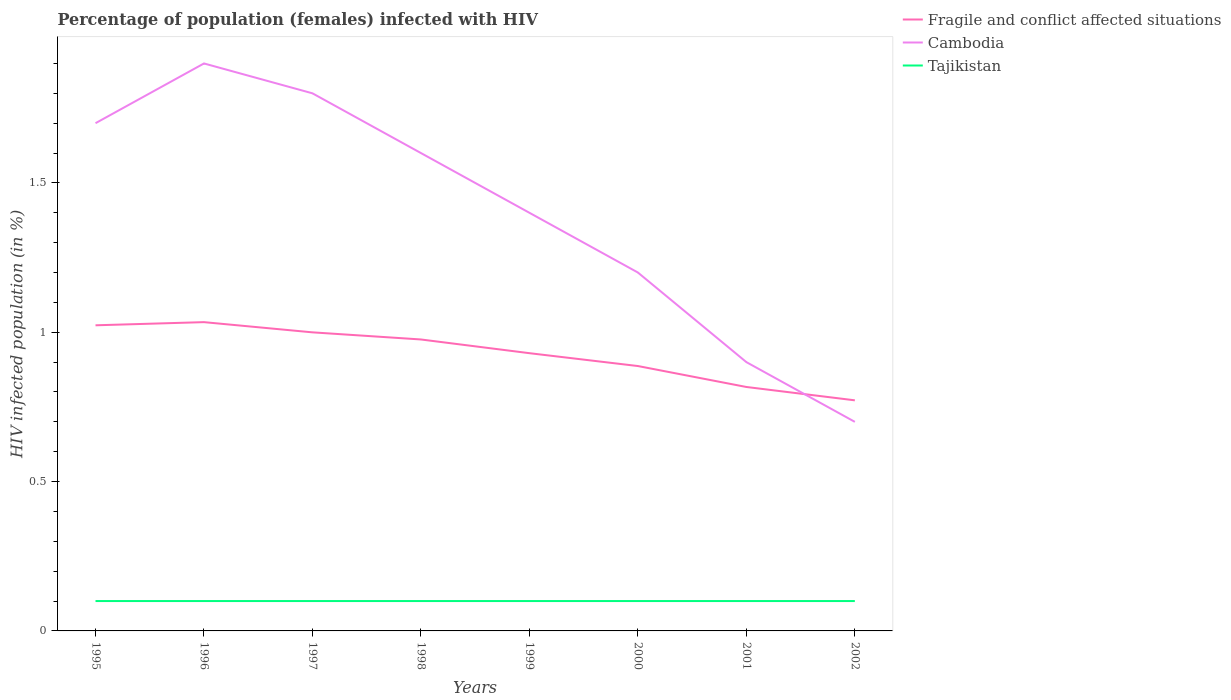How many different coloured lines are there?
Your response must be concise. 3. Is the number of lines equal to the number of legend labels?
Make the answer very short. Yes. Across all years, what is the maximum percentage of HIV infected female population in Tajikistan?
Ensure brevity in your answer.  0.1. What is the total percentage of HIV infected female population in Fragile and conflict affected situations in the graph?
Your answer should be compact. 0.25. What is the difference between the highest and the second highest percentage of HIV infected female population in Tajikistan?
Offer a terse response. 0. What is the difference between the highest and the lowest percentage of HIV infected female population in Tajikistan?
Your answer should be compact. 0. What is the difference between two consecutive major ticks on the Y-axis?
Your answer should be very brief. 0.5. Does the graph contain any zero values?
Ensure brevity in your answer.  No. Does the graph contain grids?
Give a very brief answer. No. Where does the legend appear in the graph?
Provide a short and direct response. Top right. How are the legend labels stacked?
Your answer should be compact. Vertical. What is the title of the graph?
Offer a very short reply. Percentage of population (females) infected with HIV. What is the label or title of the Y-axis?
Your answer should be very brief. HIV infected population (in %). What is the HIV infected population (in %) of Fragile and conflict affected situations in 1995?
Keep it short and to the point. 1.02. What is the HIV infected population (in %) of Cambodia in 1995?
Keep it short and to the point. 1.7. What is the HIV infected population (in %) of Fragile and conflict affected situations in 1996?
Provide a succinct answer. 1.03. What is the HIV infected population (in %) of Fragile and conflict affected situations in 1997?
Provide a succinct answer. 1. What is the HIV infected population (in %) of Tajikistan in 1997?
Ensure brevity in your answer.  0.1. What is the HIV infected population (in %) of Fragile and conflict affected situations in 1998?
Ensure brevity in your answer.  0.98. What is the HIV infected population (in %) in Cambodia in 1998?
Ensure brevity in your answer.  1.6. What is the HIV infected population (in %) in Fragile and conflict affected situations in 1999?
Give a very brief answer. 0.93. What is the HIV infected population (in %) of Cambodia in 1999?
Keep it short and to the point. 1.4. What is the HIV infected population (in %) in Fragile and conflict affected situations in 2000?
Your answer should be compact. 0.89. What is the HIV infected population (in %) of Tajikistan in 2000?
Provide a short and direct response. 0.1. What is the HIV infected population (in %) in Fragile and conflict affected situations in 2001?
Keep it short and to the point. 0.82. What is the HIV infected population (in %) in Cambodia in 2001?
Make the answer very short. 0.9. What is the HIV infected population (in %) of Tajikistan in 2001?
Your answer should be compact. 0.1. What is the HIV infected population (in %) in Fragile and conflict affected situations in 2002?
Offer a terse response. 0.77. What is the HIV infected population (in %) of Cambodia in 2002?
Keep it short and to the point. 0.7. What is the HIV infected population (in %) in Tajikistan in 2002?
Offer a very short reply. 0.1. Across all years, what is the maximum HIV infected population (in %) of Fragile and conflict affected situations?
Keep it short and to the point. 1.03. Across all years, what is the maximum HIV infected population (in %) of Cambodia?
Keep it short and to the point. 1.9. Across all years, what is the minimum HIV infected population (in %) of Fragile and conflict affected situations?
Provide a short and direct response. 0.77. Across all years, what is the minimum HIV infected population (in %) of Cambodia?
Provide a short and direct response. 0.7. What is the total HIV infected population (in %) of Fragile and conflict affected situations in the graph?
Provide a succinct answer. 7.44. What is the total HIV infected population (in %) in Cambodia in the graph?
Offer a terse response. 11.2. What is the total HIV infected population (in %) in Tajikistan in the graph?
Provide a succinct answer. 0.8. What is the difference between the HIV infected population (in %) in Fragile and conflict affected situations in 1995 and that in 1996?
Offer a terse response. -0.01. What is the difference between the HIV infected population (in %) of Cambodia in 1995 and that in 1996?
Provide a short and direct response. -0.2. What is the difference between the HIV infected population (in %) of Tajikistan in 1995 and that in 1996?
Ensure brevity in your answer.  0. What is the difference between the HIV infected population (in %) of Fragile and conflict affected situations in 1995 and that in 1997?
Your answer should be very brief. 0.02. What is the difference between the HIV infected population (in %) of Tajikistan in 1995 and that in 1997?
Make the answer very short. 0. What is the difference between the HIV infected population (in %) of Fragile and conflict affected situations in 1995 and that in 1998?
Provide a succinct answer. 0.05. What is the difference between the HIV infected population (in %) in Cambodia in 1995 and that in 1998?
Your answer should be compact. 0.1. What is the difference between the HIV infected population (in %) of Fragile and conflict affected situations in 1995 and that in 1999?
Give a very brief answer. 0.09. What is the difference between the HIV infected population (in %) in Fragile and conflict affected situations in 1995 and that in 2000?
Keep it short and to the point. 0.14. What is the difference between the HIV infected population (in %) of Cambodia in 1995 and that in 2000?
Your answer should be very brief. 0.5. What is the difference between the HIV infected population (in %) in Tajikistan in 1995 and that in 2000?
Provide a succinct answer. 0. What is the difference between the HIV infected population (in %) of Fragile and conflict affected situations in 1995 and that in 2001?
Make the answer very short. 0.21. What is the difference between the HIV infected population (in %) in Tajikistan in 1995 and that in 2001?
Ensure brevity in your answer.  0. What is the difference between the HIV infected population (in %) in Fragile and conflict affected situations in 1995 and that in 2002?
Make the answer very short. 0.25. What is the difference between the HIV infected population (in %) in Fragile and conflict affected situations in 1996 and that in 1997?
Provide a succinct answer. 0.03. What is the difference between the HIV infected population (in %) in Cambodia in 1996 and that in 1997?
Make the answer very short. 0.1. What is the difference between the HIV infected population (in %) in Fragile and conflict affected situations in 1996 and that in 1998?
Make the answer very short. 0.06. What is the difference between the HIV infected population (in %) in Fragile and conflict affected situations in 1996 and that in 1999?
Your answer should be very brief. 0.1. What is the difference between the HIV infected population (in %) in Tajikistan in 1996 and that in 1999?
Give a very brief answer. 0. What is the difference between the HIV infected population (in %) of Fragile and conflict affected situations in 1996 and that in 2000?
Your answer should be very brief. 0.15. What is the difference between the HIV infected population (in %) in Cambodia in 1996 and that in 2000?
Ensure brevity in your answer.  0.7. What is the difference between the HIV infected population (in %) in Tajikistan in 1996 and that in 2000?
Give a very brief answer. 0. What is the difference between the HIV infected population (in %) of Fragile and conflict affected situations in 1996 and that in 2001?
Your response must be concise. 0.22. What is the difference between the HIV infected population (in %) of Cambodia in 1996 and that in 2001?
Your response must be concise. 1. What is the difference between the HIV infected population (in %) in Tajikistan in 1996 and that in 2001?
Your response must be concise. 0. What is the difference between the HIV infected population (in %) of Fragile and conflict affected situations in 1996 and that in 2002?
Offer a terse response. 0.26. What is the difference between the HIV infected population (in %) in Fragile and conflict affected situations in 1997 and that in 1998?
Your answer should be compact. 0.02. What is the difference between the HIV infected population (in %) of Cambodia in 1997 and that in 1998?
Make the answer very short. 0.2. What is the difference between the HIV infected population (in %) in Fragile and conflict affected situations in 1997 and that in 1999?
Offer a very short reply. 0.07. What is the difference between the HIV infected population (in %) of Cambodia in 1997 and that in 1999?
Offer a very short reply. 0.4. What is the difference between the HIV infected population (in %) of Fragile and conflict affected situations in 1997 and that in 2000?
Give a very brief answer. 0.11. What is the difference between the HIV infected population (in %) of Tajikistan in 1997 and that in 2000?
Make the answer very short. 0. What is the difference between the HIV infected population (in %) of Fragile and conflict affected situations in 1997 and that in 2001?
Your answer should be compact. 0.18. What is the difference between the HIV infected population (in %) of Fragile and conflict affected situations in 1997 and that in 2002?
Give a very brief answer. 0.23. What is the difference between the HIV infected population (in %) of Cambodia in 1997 and that in 2002?
Make the answer very short. 1.1. What is the difference between the HIV infected population (in %) in Fragile and conflict affected situations in 1998 and that in 1999?
Your answer should be compact. 0.05. What is the difference between the HIV infected population (in %) in Cambodia in 1998 and that in 1999?
Your answer should be compact. 0.2. What is the difference between the HIV infected population (in %) of Tajikistan in 1998 and that in 1999?
Make the answer very short. 0. What is the difference between the HIV infected population (in %) in Fragile and conflict affected situations in 1998 and that in 2000?
Give a very brief answer. 0.09. What is the difference between the HIV infected population (in %) of Cambodia in 1998 and that in 2000?
Your answer should be compact. 0.4. What is the difference between the HIV infected population (in %) in Tajikistan in 1998 and that in 2000?
Offer a terse response. 0. What is the difference between the HIV infected population (in %) of Fragile and conflict affected situations in 1998 and that in 2001?
Give a very brief answer. 0.16. What is the difference between the HIV infected population (in %) in Fragile and conflict affected situations in 1998 and that in 2002?
Ensure brevity in your answer.  0.2. What is the difference between the HIV infected population (in %) of Cambodia in 1998 and that in 2002?
Offer a terse response. 0.9. What is the difference between the HIV infected population (in %) of Tajikistan in 1998 and that in 2002?
Offer a very short reply. 0. What is the difference between the HIV infected population (in %) in Fragile and conflict affected situations in 1999 and that in 2000?
Ensure brevity in your answer.  0.04. What is the difference between the HIV infected population (in %) of Cambodia in 1999 and that in 2000?
Your answer should be compact. 0.2. What is the difference between the HIV infected population (in %) in Fragile and conflict affected situations in 1999 and that in 2001?
Your answer should be compact. 0.11. What is the difference between the HIV infected population (in %) of Cambodia in 1999 and that in 2001?
Your response must be concise. 0.5. What is the difference between the HIV infected population (in %) of Tajikistan in 1999 and that in 2001?
Provide a succinct answer. 0. What is the difference between the HIV infected population (in %) in Fragile and conflict affected situations in 1999 and that in 2002?
Offer a terse response. 0.16. What is the difference between the HIV infected population (in %) of Cambodia in 1999 and that in 2002?
Give a very brief answer. 0.7. What is the difference between the HIV infected population (in %) of Fragile and conflict affected situations in 2000 and that in 2001?
Provide a short and direct response. 0.07. What is the difference between the HIV infected population (in %) of Cambodia in 2000 and that in 2001?
Make the answer very short. 0.3. What is the difference between the HIV infected population (in %) in Fragile and conflict affected situations in 2000 and that in 2002?
Make the answer very short. 0.11. What is the difference between the HIV infected population (in %) in Cambodia in 2000 and that in 2002?
Your answer should be very brief. 0.5. What is the difference between the HIV infected population (in %) of Fragile and conflict affected situations in 2001 and that in 2002?
Ensure brevity in your answer.  0.04. What is the difference between the HIV infected population (in %) in Cambodia in 2001 and that in 2002?
Make the answer very short. 0.2. What is the difference between the HIV infected population (in %) in Tajikistan in 2001 and that in 2002?
Your response must be concise. 0. What is the difference between the HIV infected population (in %) in Fragile and conflict affected situations in 1995 and the HIV infected population (in %) in Cambodia in 1996?
Your response must be concise. -0.88. What is the difference between the HIV infected population (in %) of Fragile and conflict affected situations in 1995 and the HIV infected population (in %) of Tajikistan in 1996?
Make the answer very short. 0.92. What is the difference between the HIV infected population (in %) in Fragile and conflict affected situations in 1995 and the HIV infected population (in %) in Cambodia in 1997?
Provide a succinct answer. -0.78. What is the difference between the HIV infected population (in %) of Fragile and conflict affected situations in 1995 and the HIV infected population (in %) of Tajikistan in 1997?
Offer a terse response. 0.92. What is the difference between the HIV infected population (in %) in Cambodia in 1995 and the HIV infected population (in %) in Tajikistan in 1997?
Your response must be concise. 1.6. What is the difference between the HIV infected population (in %) in Fragile and conflict affected situations in 1995 and the HIV infected population (in %) in Cambodia in 1998?
Provide a short and direct response. -0.58. What is the difference between the HIV infected population (in %) in Fragile and conflict affected situations in 1995 and the HIV infected population (in %) in Tajikistan in 1998?
Keep it short and to the point. 0.92. What is the difference between the HIV infected population (in %) in Cambodia in 1995 and the HIV infected population (in %) in Tajikistan in 1998?
Ensure brevity in your answer.  1.6. What is the difference between the HIV infected population (in %) of Fragile and conflict affected situations in 1995 and the HIV infected population (in %) of Cambodia in 1999?
Offer a very short reply. -0.38. What is the difference between the HIV infected population (in %) of Fragile and conflict affected situations in 1995 and the HIV infected population (in %) of Tajikistan in 1999?
Your answer should be very brief. 0.92. What is the difference between the HIV infected population (in %) of Cambodia in 1995 and the HIV infected population (in %) of Tajikistan in 1999?
Your answer should be very brief. 1.6. What is the difference between the HIV infected population (in %) in Fragile and conflict affected situations in 1995 and the HIV infected population (in %) in Cambodia in 2000?
Keep it short and to the point. -0.18. What is the difference between the HIV infected population (in %) of Fragile and conflict affected situations in 1995 and the HIV infected population (in %) of Tajikistan in 2000?
Provide a short and direct response. 0.92. What is the difference between the HIV infected population (in %) in Cambodia in 1995 and the HIV infected population (in %) in Tajikistan in 2000?
Make the answer very short. 1.6. What is the difference between the HIV infected population (in %) in Fragile and conflict affected situations in 1995 and the HIV infected population (in %) in Cambodia in 2001?
Your answer should be very brief. 0.12. What is the difference between the HIV infected population (in %) in Fragile and conflict affected situations in 1995 and the HIV infected population (in %) in Tajikistan in 2001?
Give a very brief answer. 0.92. What is the difference between the HIV infected population (in %) of Cambodia in 1995 and the HIV infected population (in %) of Tajikistan in 2001?
Provide a short and direct response. 1.6. What is the difference between the HIV infected population (in %) in Fragile and conflict affected situations in 1995 and the HIV infected population (in %) in Cambodia in 2002?
Your answer should be compact. 0.32. What is the difference between the HIV infected population (in %) of Fragile and conflict affected situations in 1995 and the HIV infected population (in %) of Tajikistan in 2002?
Provide a succinct answer. 0.92. What is the difference between the HIV infected population (in %) in Cambodia in 1995 and the HIV infected population (in %) in Tajikistan in 2002?
Keep it short and to the point. 1.6. What is the difference between the HIV infected population (in %) in Fragile and conflict affected situations in 1996 and the HIV infected population (in %) in Cambodia in 1997?
Offer a terse response. -0.77. What is the difference between the HIV infected population (in %) in Fragile and conflict affected situations in 1996 and the HIV infected population (in %) in Tajikistan in 1997?
Your answer should be compact. 0.93. What is the difference between the HIV infected population (in %) in Cambodia in 1996 and the HIV infected population (in %) in Tajikistan in 1997?
Provide a short and direct response. 1.8. What is the difference between the HIV infected population (in %) in Fragile and conflict affected situations in 1996 and the HIV infected population (in %) in Cambodia in 1998?
Your answer should be very brief. -0.57. What is the difference between the HIV infected population (in %) of Fragile and conflict affected situations in 1996 and the HIV infected population (in %) of Tajikistan in 1998?
Your answer should be compact. 0.93. What is the difference between the HIV infected population (in %) in Cambodia in 1996 and the HIV infected population (in %) in Tajikistan in 1998?
Offer a terse response. 1.8. What is the difference between the HIV infected population (in %) of Fragile and conflict affected situations in 1996 and the HIV infected population (in %) of Cambodia in 1999?
Keep it short and to the point. -0.37. What is the difference between the HIV infected population (in %) of Fragile and conflict affected situations in 1996 and the HIV infected population (in %) of Tajikistan in 1999?
Offer a terse response. 0.93. What is the difference between the HIV infected population (in %) in Cambodia in 1996 and the HIV infected population (in %) in Tajikistan in 1999?
Provide a short and direct response. 1.8. What is the difference between the HIV infected population (in %) of Fragile and conflict affected situations in 1996 and the HIV infected population (in %) of Cambodia in 2000?
Ensure brevity in your answer.  -0.17. What is the difference between the HIV infected population (in %) in Fragile and conflict affected situations in 1996 and the HIV infected population (in %) in Tajikistan in 2000?
Ensure brevity in your answer.  0.93. What is the difference between the HIV infected population (in %) in Cambodia in 1996 and the HIV infected population (in %) in Tajikistan in 2000?
Offer a very short reply. 1.8. What is the difference between the HIV infected population (in %) in Fragile and conflict affected situations in 1996 and the HIV infected population (in %) in Cambodia in 2001?
Provide a succinct answer. 0.13. What is the difference between the HIV infected population (in %) in Fragile and conflict affected situations in 1996 and the HIV infected population (in %) in Tajikistan in 2001?
Your answer should be compact. 0.93. What is the difference between the HIV infected population (in %) of Fragile and conflict affected situations in 1996 and the HIV infected population (in %) of Cambodia in 2002?
Keep it short and to the point. 0.33. What is the difference between the HIV infected population (in %) in Fragile and conflict affected situations in 1996 and the HIV infected population (in %) in Tajikistan in 2002?
Provide a succinct answer. 0.93. What is the difference between the HIV infected population (in %) of Cambodia in 1996 and the HIV infected population (in %) of Tajikistan in 2002?
Provide a short and direct response. 1.8. What is the difference between the HIV infected population (in %) in Fragile and conflict affected situations in 1997 and the HIV infected population (in %) in Cambodia in 1998?
Give a very brief answer. -0.6. What is the difference between the HIV infected population (in %) in Fragile and conflict affected situations in 1997 and the HIV infected population (in %) in Tajikistan in 1998?
Your answer should be very brief. 0.9. What is the difference between the HIV infected population (in %) of Fragile and conflict affected situations in 1997 and the HIV infected population (in %) of Cambodia in 1999?
Keep it short and to the point. -0.4. What is the difference between the HIV infected population (in %) of Fragile and conflict affected situations in 1997 and the HIV infected population (in %) of Tajikistan in 1999?
Make the answer very short. 0.9. What is the difference between the HIV infected population (in %) in Fragile and conflict affected situations in 1997 and the HIV infected population (in %) in Cambodia in 2000?
Provide a short and direct response. -0.2. What is the difference between the HIV infected population (in %) of Fragile and conflict affected situations in 1997 and the HIV infected population (in %) of Tajikistan in 2000?
Provide a succinct answer. 0.9. What is the difference between the HIV infected population (in %) in Cambodia in 1997 and the HIV infected population (in %) in Tajikistan in 2000?
Ensure brevity in your answer.  1.7. What is the difference between the HIV infected population (in %) in Fragile and conflict affected situations in 1997 and the HIV infected population (in %) in Cambodia in 2001?
Offer a very short reply. 0.1. What is the difference between the HIV infected population (in %) of Fragile and conflict affected situations in 1997 and the HIV infected population (in %) of Tajikistan in 2001?
Provide a short and direct response. 0.9. What is the difference between the HIV infected population (in %) of Fragile and conflict affected situations in 1997 and the HIV infected population (in %) of Cambodia in 2002?
Ensure brevity in your answer.  0.3. What is the difference between the HIV infected population (in %) of Fragile and conflict affected situations in 1997 and the HIV infected population (in %) of Tajikistan in 2002?
Give a very brief answer. 0.9. What is the difference between the HIV infected population (in %) of Fragile and conflict affected situations in 1998 and the HIV infected population (in %) of Cambodia in 1999?
Offer a very short reply. -0.42. What is the difference between the HIV infected population (in %) of Fragile and conflict affected situations in 1998 and the HIV infected population (in %) of Tajikistan in 1999?
Keep it short and to the point. 0.88. What is the difference between the HIV infected population (in %) of Cambodia in 1998 and the HIV infected population (in %) of Tajikistan in 1999?
Make the answer very short. 1.5. What is the difference between the HIV infected population (in %) of Fragile and conflict affected situations in 1998 and the HIV infected population (in %) of Cambodia in 2000?
Your answer should be very brief. -0.22. What is the difference between the HIV infected population (in %) in Fragile and conflict affected situations in 1998 and the HIV infected population (in %) in Tajikistan in 2000?
Ensure brevity in your answer.  0.88. What is the difference between the HIV infected population (in %) in Cambodia in 1998 and the HIV infected population (in %) in Tajikistan in 2000?
Provide a succinct answer. 1.5. What is the difference between the HIV infected population (in %) in Fragile and conflict affected situations in 1998 and the HIV infected population (in %) in Cambodia in 2001?
Your answer should be very brief. 0.08. What is the difference between the HIV infected population (in %) of Fragile and conflict affected situations in 1998 and the HIV infected population (in %) of Tajikistan in 2001?
Your answer should be compact. 0.88. What is the difference between the HIV infected population (in %) of Fragile and conflict affected situations in 1998 and the HIV infected population (in %) of Cambodia in 2002?
Your answer should be compact. 0.28. What is the difference between the HIV infected population (in %) of Fragile and conflict affected situations in 1998 and the HIV infected population (in %) of Tajikistan in 2002?
Your answer should be compact. 0.88. What is the difference between the HIV infected population (in %) of Cambodia in 1998 and the HIV infected population (in %) of Tajikistan in 2002?
Provide a succinct answer. 1.5. What is the difference between the HIV infected population (in %) in Fragile and conflict affected situations in 1999 and the HIV infected population (in %) in Cambodia in 2000?
Your answer should be compact. -0.27. What is the difference between the HIV infected population (in %) in Fragile and conflict affected situations in 1999 and the HIV infected population (in %) in Tajikistan in 2000?
Provide a succinct answer. 0.83. What is the difference between the HIV infected population (in %) of Fragile and conflict affected situations in 1999 and the HIV infected population (in %) of Cambodia in 2001?
Your answer should be very brief. 0.03. What is the difference between the HIV infected population (in %) in Fragile and conflict affected situations in 1999 and the HIV infected population (in %) in Tajikistan in 2001?
Your answer should be very brief. 0.83. What is the difference between the HIV infected population (in %) in Fragile and conflict affected situations in 1999 and the HIV infected population (in %) in Cambodia in 2002?
Offer a terse response. 0.23. What is the difference between the HIV infected population (in %) in Fragile and conflict affected situations in 1999 and the HIV infected population (in %) in Tajikistan in 2002?
Keep it short and to the point. 0.83. What is the difference between the HIV infected population (in %) of Fragile and conflict affected situations in 2000 and the HIV infected population (in %) of Cambodia in 2001?
Provide a succinct answer. -0.01. What is the difference between the HIV infected population (in %) of Fragile and conflict affected situations in 2000 and the HIV infected population (in %) of Tajikistan in 2001?
Your answer should be compact. 0.79. What is the difference between the HIV infected population (in %) of Fragile and conflict affected situations in 2000 and the HIV infected population (in %) of Cambodia in 2002?
Give a very brief answer. 0.19. What is the difference between the HIV infected population (in %) in Fragile and conflict affected situations in 2000 and the HIV infected population (in %) in Tajikistan in 2002?
Ensure brevity in your answer.  0.79. What is the difference between the HIV infected population (in %) in Fragile and conflict affected situations in 2001 and the HIV infected population (in %) in Cambodia in 2002?
Keep it short and to the point. 0.12. What is the difference between the HIV infected population (in %) in Fragile and conflict affected situations in 2001 and the HIV infected population (in %) in Tajikistan in 2002?
Make the answer very short. 0.72. What is the difference between the HIV infected population (in %) in Cambodia in 2001 and the HIV infected population (in %) in Tajikistan in 2002?
Ensure brevity in your answer.  0.8. What is the average HIV infected population (in %) of Fragile and conflict affected situations per year?
Give a very brief answer. 0.93. In the year 1995, what is the difference between the HIV infected population (in %) in Fragile and conflict affected situations and HIV infected population (in %) in Cambodia?
Give a very brief answer. -0.68. In the year 1995, what is the difference between the HIV infected population (in %) in Fragile and conflict affected situations and HIV infected population (in %) in Tajikistan?
Your answer should be very brief. 0.92. In the year 1996, what is the difference between the HIV infected population (in %) in Fragile and conflict affected situations and HIV infected population (in %) in Cambodia?
Offer a very short reply. -0.87. In the year 1996, what is the difference between the HIV infected population (in %) in Fragile and conflict affected situations and HIV infected population (in %) in Tajikistan?
Keep it short and to the point. 0.93. In the year 1997, what is the difference between the HIV infected population (in %) in Fragile and conflict affected situations and HIV infected population (in %) in Cambodia?
Provide a succinct answer. -0.8. In the year 1997, what is the difference between the HIV infected population (in %) of Fragile and conflict affected situations and HIV infected population (in %) of Tajikistan?
Provide a short and direct response. 0.9. In the year 1997, what is the difference between the HIV infected population (in %) of Cambodia and HIV infected population (in %) of Tajikistan?
Offer a terse response. 1.7. In the year 1998, what is the difference between the HIV infected population (in %) in Fragile and conflict affected situations and HIV infected population (in %) in Cambodia?
Your response must be concise. -0.62. In the year 1998, what is the difference between the HIV infected population (in %) of Fragile and conflict affected situations and HIV infected population (in %) of Tajikistan?
Keep it short and to the point. 0.88. In the year 1999, what is the difference between the HIV infected population (in %) in Fragile and conflict affected situations and HIV infected population (in %) in Cambodia?
Make the answer very short. -0.47. In the year 1999, what is the difference between the HIV infected population (in %) in Fragile and conflict affected situations and HIV infected population (in %) in Tajikistan?
Make the answer very short. 0.83. In the year 1999, what is the difference between the HIV infected population (in %) in Cambodia and HIV infected population (in %) in Tajikistan?
Provide a short and direct response. 1.3. In the year 2000, what is the difference between the HIV infected population (in %) of Fragile and conflict affected situations and HIV infected population (in %) of Cambodia?
Offer a very short reply. -0.31. In the year 2000, what is the difference between the HIV infected population (in %) of Fragile and conflict affected situations and HIV infected population (in %) of Tajikistan?
Keep it short and to the point. 0.79. In the year 2001, what is the difference between the HIV infected population (in %) in Fragile and conflict affected situations and HIV infected population (in %) in Cambodia?
Make the answer very short. -0.08. In the year 2001, what is the difference between the HIV infected population (in %) in Fragile and conflict affected situations and HIV infected population (in %) in Tajikistan?
Keep it short and to the point. 0.72. In the year 2001, what is the difference between the HIV infected population (in %) in Cambodia and HIV infected population (in %) in Tajikistan?
Your response must be concise. 0.8. In the year 2002, what is the difference between the HIV infected population (in %) in Fragile and conflict affected situations and HIV infected population (in %) in Cambodia?
Your response must be concise. 0.07. In the year 2002, what is the difference between the HIV infected population (in %) of Fragile and conflict affected situations and HIV infected population (in %) of Tajikistan?
Offer a very short reply. 0.67. What is the ratio of the HIV infected population (in %) in Cambodia in 1995 to that in 1996?
Offer a very short reply. 0.89. What is the ratio of the HIV infected population (in %) of Fragile and conflict affected situations in 1995 to that in 1997?
Provide a short and direct response. 1.02. What is the ratio of the HIV infected population (in %) in Tajikistan in 1995 to that in 1997?
Provide a succinct answer. 1. What is the ratio of the HIV infected population (in %) of Fragile and conflict affected situations in 1995 to that in 1998?
Give a very brief answer. 1.05. What is the ratio of the HIV infected population (in %) in Tajikistan in 1995 to that in 1998?
Your answer should be very brief. 1. What is the ratio of the HIV infected population (in %) in Fragile and conflict affected situations in 1995 to that in 1999?
Keep it short and to the point. 1.1. What is the ratio of the HIV infected population (in %) in Cambodia in 1995 to that in 1999?
Make the answer very short. 1.21. What is the ratio of the HIV infected population (in %) of Fragile and conflict affected situations in 1995 to that in 2000?
Provide a short and direct response. 1.15. What is the ratio of the HIV infected population (in %) of Cambodia in 1995 to that in 2000?
Offer a very short reply. 1.42. What is the ratio of the HIV infected population (in %) of Tajikistan in 1995 to that in 2000?
Ensure brevity in your answer.  1. What is the ratio of the HIV infected population (in %) of Fragile and conflict affected situations in 1995 to that in 2001?
Give a very brief answer. 1.25. What is the ratio of the HIV infected population (in %) of Cambodia in 1995 to that in 2001?
Keep it short and to the point. 1.89. What is the ratio of the HIV infected population (in %) of Tajikistan in 1995 to that in 2001?
Your answer should be compact. 1. What is the ratio of the HIV infected population (in %) of Fragile and conflict affected situations in 1995 to that in 2002?
Provide a short and direct response. 1.33. What is the ratio of the HIV infected population (in %) in Cambodia in 1995 to that in 2002?
Make the answer very short. 2.43. What is the ratio of the HIV infected population (in %) in Fragile and conflict affected situations in 1996 to that in 1997?
Offer a very short reply. 1.03. What is the ratio of the HIV infected population (in %) in Cambodia in 1996 to that in 1997?
Give a very brief answer. 1.06. What is the ratio of the HIV infected population (in %) of Tajikistan in 1996 to that in 1997?
Keep it short and to the point. 1. What is the ratio of the HIV infected population (in %) of Fragile and conflict affected situations in 1996 to that in 1998?
Your answer should be very brief. 1.06. What is the ratio of the HIV infected population (in %) in Cambodia in 1996 to that in 1998?
Ensure brevity in your answer.  1.19. What is the ratio of the HIV infected population (in %) of Fragile and conflict affected situations in 1996 to that in 1999?
Offer a very short reply. 1.11. What is the ratio of the HIV infected population (in %) of Cambodia in 1996 to that in 1999?
Your response must be concise. 1.36. What is the ratio of the HIV infected population (in %) in Fragile and conflict affected situations in 1996 to that in 2000?
Your response must be concise. 1.17. What is the ratio of the HIV infected population (in %) of Cambodia in 1996 to that in 2000?
Offer a very short reply. 1.58. What is the ratio of the HIV infected population (in %) in Fragile and conflict affected situations in 1996 to that in 2001?
Offer a terse response. 1.27. What is the ratio of the HIV infected population (in %) of Cambodia in 1996 to that in 2001?
Give a very brief answer. 2.11. What is the ratio of the HIV infected population (in %) of Tajikistan in 1996 to that in 2001?
Offer a terse response. 1. What is the ratio of the HIV infected population (in %) of Fragile and conflict affected situations in 1996 to that in 2002?
Give a very brief answer. 1.34. What is the ratio of the HIV infected population (in %) in Cambodia in 1996 to that in 2002?
Your answer should be compact. 2.71. What is the ratio of the HIV infected population (in %) in Tajikistan in 1996 to that in 2002?
Ensure brevity in your answer.  1. What is the ratio of the HIV infected population (in %) of Fragile and conflict affected situations in 1997 to that in 1998?
Make the answer very short. 1.02. What is the ratio of the HIV infected population (in %) of Tajikistan in 1997 to that in 1998?
Provide a succinct answer. 1. What is the ratio of the HIV infected population (in %) in Fragile and conflict affected situations in 1997 to that in 1999?
Your response must be concise. 1.07. What is the ratio of the HIV infected population (in %) in Cambodia in 1997 to that in 1999?
Provide a short and direct response. 1.29. What is the ratio of the HIV infected population (in %) of Tajikistan in 1997 to that in 1999?
Your response must be concise. 1. What is the ratio of the HIV infected population (in %) of Fragile and conflict affected situations in 1997 to that in 2000?
Give a very brief answer. 1.13. What is the ratio of the HIV infected population (in %) of Cambodia in 1997 to that in 2000?
Offer a very short reply. 1.5. What is the ratio of the HIV infected population (in %) of Fragile and conflict affected situations in 1997 to that in 2001?
Keep it short and to the point. 1.22. What is the ratio of the HIV infected population (in %) in Tajikistan in 1997 to that in 2001?
Your answer should be very brief. 1. What is the ratio of the HIV infected population (in %) of Fragile and conflict affected situations in 1997 to that in 2002?
Offer a very short reply. 1.29. What is the ratio of the HIV infected population (in %) in Cambodia in 1997 to that in 2002?
Your answer should be very brief. 2.57. What is the ratio of the HIV infected population (in %) in Tajikistan in 1997 to that in 2002?
Your answer should be compact. 1. What is the ratio of the HIV infected population (in %) in Fragile and conflict affected situations in 1998 to that in 1999?
Your answer should be very brief. 1.05. What is the ratio of the HIV infected population (in %) in Cambodia in 1998 to that in 1999?
Your answer should be compact. 1.14. What is the ratio of the HIV infected population (in %) of Tajikistan in 1998 to that in 1999?
Ensure brevity in your answer.  1. What is the ratio of the HIV infected population (in %) in Fragile and conflict affected situations in 1998 to that in 2000?
Offer a terse response. 1.1. What is the ratio of the HIV infected population (in %) of Cambodia in 1998 to that in 2000?
Make the answer very short. 1.33. What is the ratio of the HIV infected population (in %) of Fragile and conflict affected situations in 1998 to that in 2001?
Offer a terse response. 1.19. What is the ratio of the HIV infected population (in %) in Cambodia in 1998 to that in 2001?
Make the answer very short. 1.78. What is the ratio of the HIV infected population (in %) of Fragile and conflict affected situations in 1998 to that in 2002?
Keep it short and to the point. 1.26. What is the ratio of the HIV infected population (in %) of Cambodia in 1998 to that in 2002?
Offer a very short reply. 2.29. What is the ratio of the HIV infected population (in %) in Tajikistan in 1998 to that in 2002?
Offer a terse response. 1. What is the ratio of the HIV infected population (in %) in Fragile and conflict affected situations in 1999 to that in 2000?
Provide a succinct answer. 1.05. What is the ratio of the HIV infected population (in %) of Fragile and conflict affected situations in 1999 to that in 2001?
Offer a terse response. 1.14. What is the ratio of the HIV infected population (in %) of Cambodia in 1999 to that in 2001?
Offer a terse response. 1.56. What is the ratio of the HIV infected population (in %) of Fragile and conflict affected situations in 1999 to that in 2002?
Offer a terse response. 1.2. What is the ratio of the HIV infected population (in %) of Cambodia in 1999 to that in 2002?
Your answer should be compact. 2. What is the ratio of the HIV infected population (in %) of Tajikistan in 1999 to that in 2002?
Your answer should be very brief. 1. What is the ratio of the HIV infected population (in %) of Fragile and conflict affected situations in 2000 to that in 2001?
Give a very brief answer. 1.09. What is the ratio of the HIV infected population (in %) in Cambodia in 2000 to that in 2001?
Your response must be concise. 1.33. What is the ratio of the HIV infected population (in %) of Tajikistan in 2000 to that in 2001?
Your response must be concise. 1. What is the ratio of the HIV infected population (in %) in Fragile and conflict affected situations in 2000 to that in 2002?
Your response must be concise. 1.15. What is the ratio of the HIV infected population (in %) of Cambodia in 2000 to that in 2002?
Your response must be concise. 1.71. What is the ratio of the HIV infected population (in %) in Fragile and conflict affected situations in 2001 to that in 2002?
Offer a terse response. 1.06. What is the ratio of the HIV infected population (in %) in Cambodia in 2001 to that in 2002?
Provide a succinct answer. 1.29. What is the difference between the highest and the second highest HIV infected population (in %) of Fragile and conflict affected situations?
Provide a succinct answer. 0.01. What is the difference between the highest and the second highest HIV infected population (in %) in Tajikistan?
Provide a short and direct response. 0. What is the difference between the highest and the lowest HIV infected population (in %) of Fragile and conflict affected situations?
Give a very brief answer. 0.26. What is the difference between the highest and the lowest HIV infected population (in %) in Cambodia?
Offer a terse response. 1.2. What is the difference between the highest and the lowest HIV infected population (in %) of Tajikistan?
Offer a very short reply. 0. 